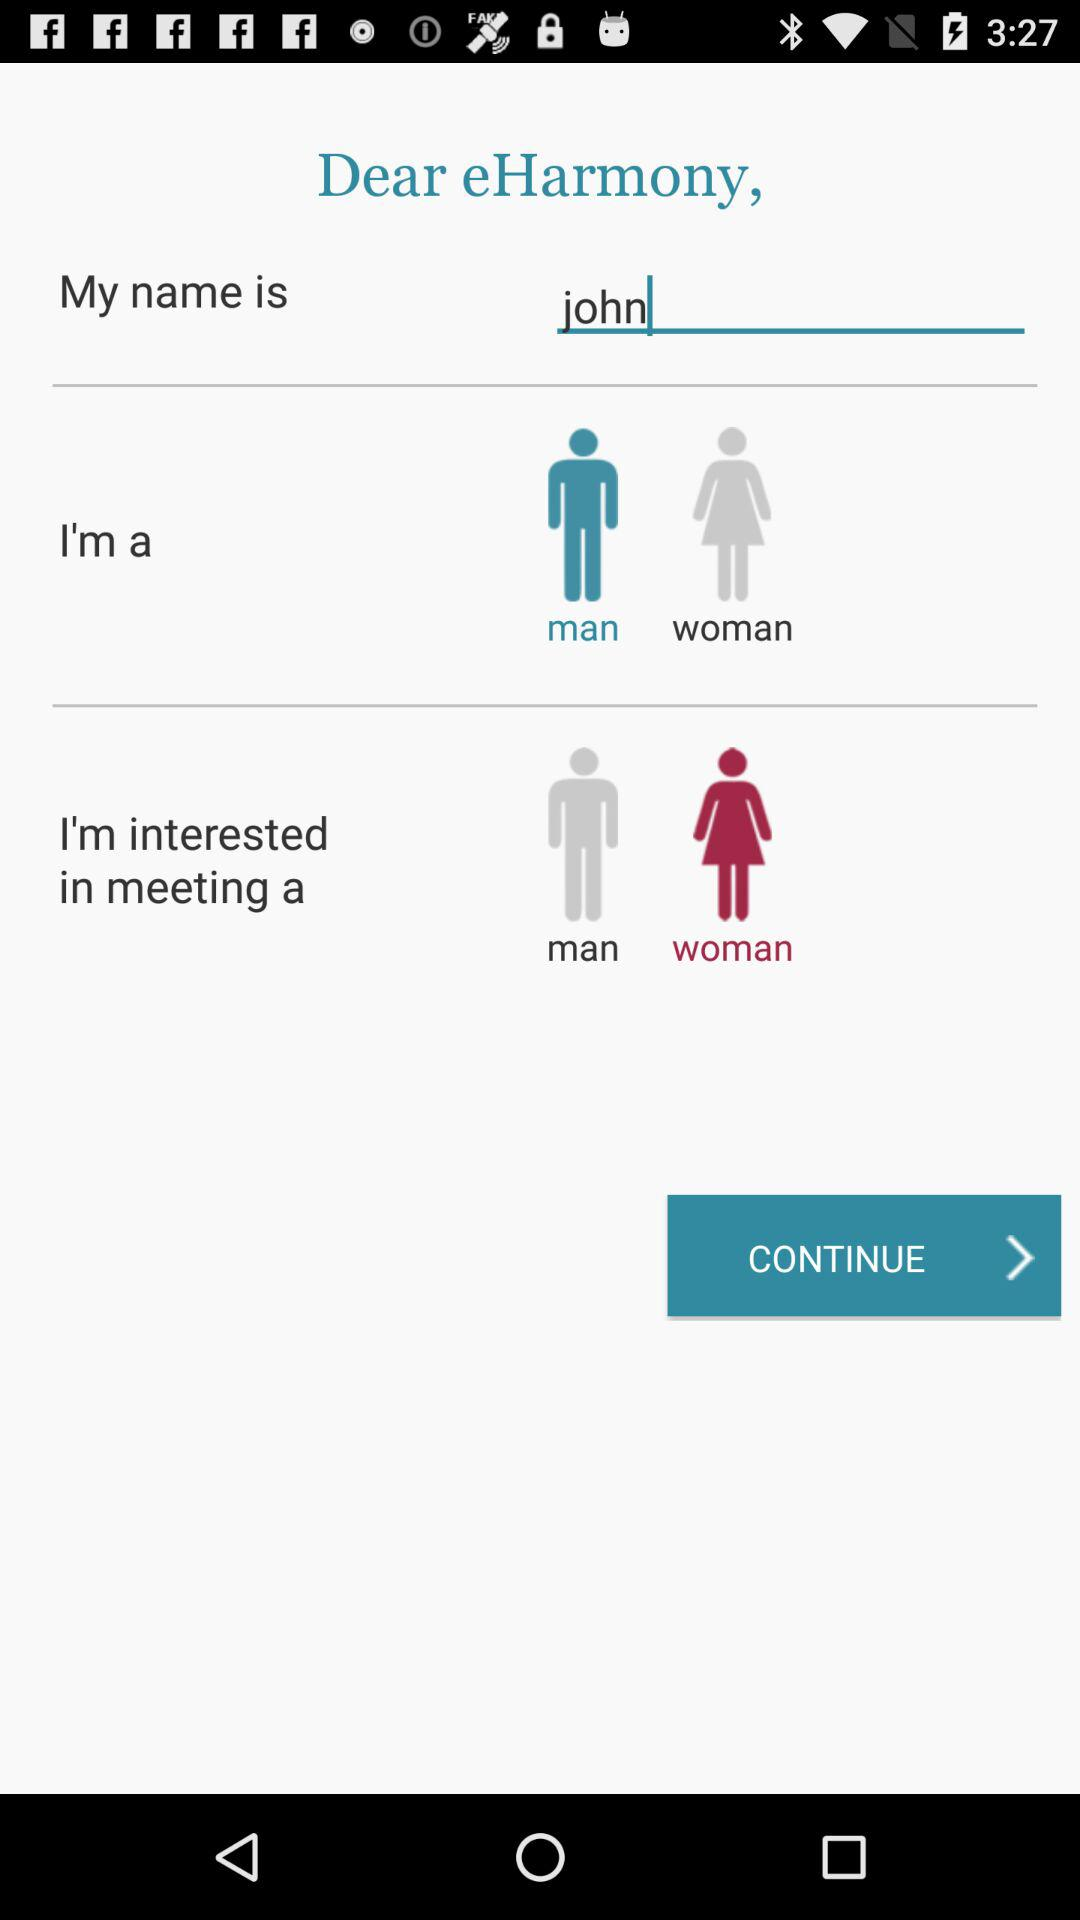What is the application name? The application name is "eHarmony". 